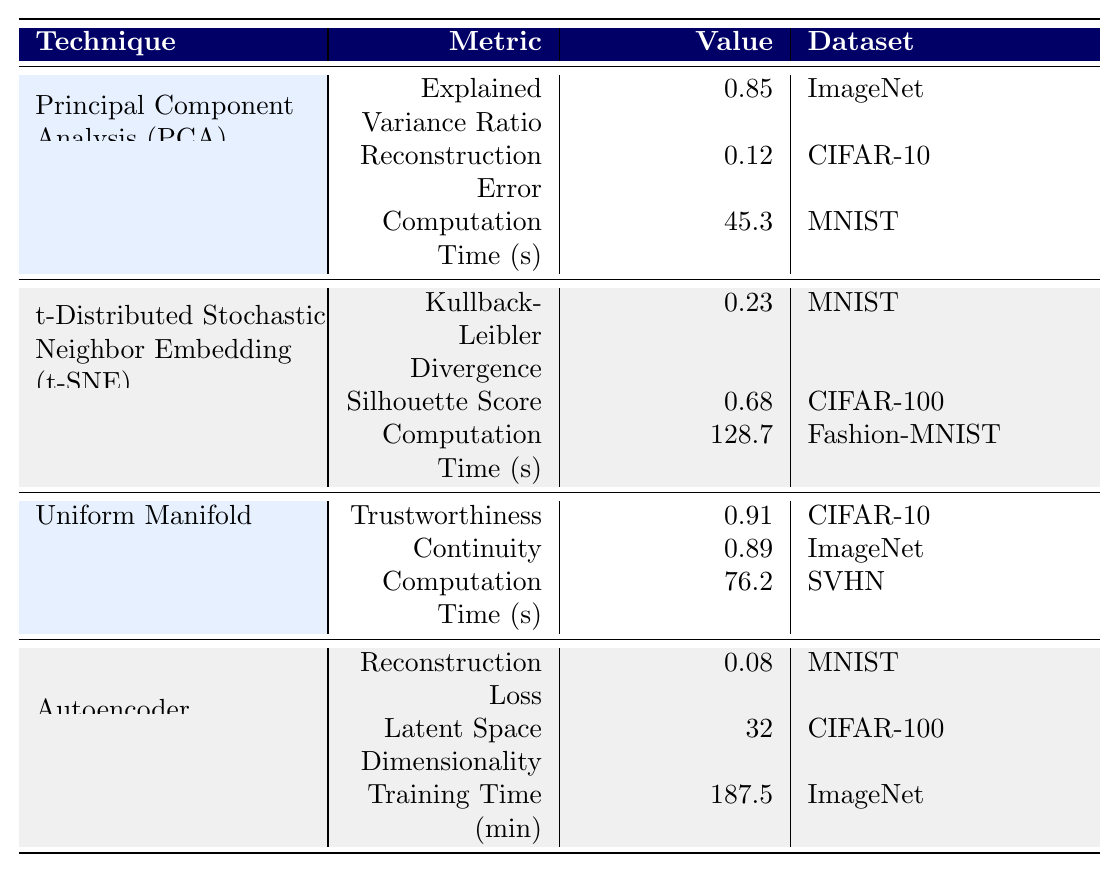What is the Reconstruction Loss for Autoencoder on the MNIST dataset? The table states the Reconstruction Loss for Autoencoder on MNIST, which is explicitly listed as 0.08.
Answer: 0.08 Which technique has the highest Explained Variance Ratio? By looking at the performance metrics, PCA has an Explained Variance Ratio of 0.85, which is the highest compared to the other techniques.
Answer: PCA What is the computation time for t-SNE on Fashion-MNIST? The table explicitly lists the computation time for t-SNE on Fashion-MNIST as 128.7 seconds.
Answer: 128.7 seconds Which dimensionality reduction technique has the lowest reconstruction error? The table shows that Autoencoder has a Reconstruction Loss of 0.08, which is lower than PCA's Reconstruction Error of 0.12.
Answer: Autoencoder What is the average Computation Time of PCA and UMAP? The computation time for PCA is 45.3 seconds and for UMAP, it is 76.2 seconds. Their average is (45.3 + 76.2) / 2 = 60.75 seconds.
Answer: 60.75 seconds Is the Trustworthiness value for UMAP greater than 0.85? The Trustworthiness value listed for UMAP is 0.91, which is indeed greater than 0.85.
Answer: Yes Which technique has the longest training time, and how long is it? According to the table, Autoencoder has a Training Time of 187.5 minutes, which is longer than any other technique.
Answer: Autoencoder, 187.5 minutes What is the difference between the Silhouette Score of t-SNE and the Explained Variance Ratio of PCA? The Silhouette Score for t-SNE is 0.68 and the Explained Variance Ratio for PCA is 0.85. The difference is 0.85 - 0.68 = 0.17.
Answer: 0.17 Is t-SNE more computationally expensive than PCA? The computation time for t-SNE is 128.7 seconds, while for PCA it is 45.3 seconds. Since 128.7 is greater than 45.3, t-SNE is more computationally expensive.
Answer: Yes Which technique shows the highest values across different performance metrics? Comparing different techniques, UMAP consistently has high values: Trustworthiness (0.91) and Continuity (0.89) indicate strong performance, but there is no single highest across all techniques. Overall, UMAP ranks highly across its metrics.
Answer: UMAP 